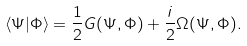<formula> <loc_0><loc_0><loc_500><loc_500>\langle \Psi | \Phi \rangle = \frac { 1 } { 2 } G ( \Psi , \Phi ) + \frac { i } { 2 } \Omega ( \Psi , \Phi ) .</formula> 